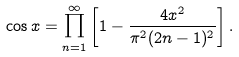<formula> <loc_0><loc_0><loc_500><loc_500>\cos x = \prod _ { n = 1 } ^ { \infty } \left [ 1 - \frac { 4 x ^ { 2 } } { \pi ^ { 2 } ( 2 n - 1 ) ^ { 2 } } \right ] .</formula> 